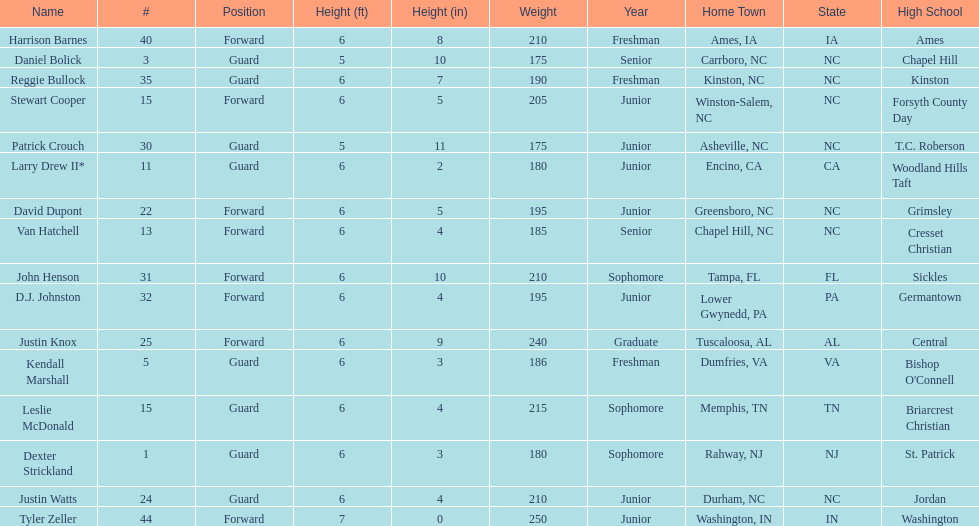What is the number of players with a weight over 200? 7. 